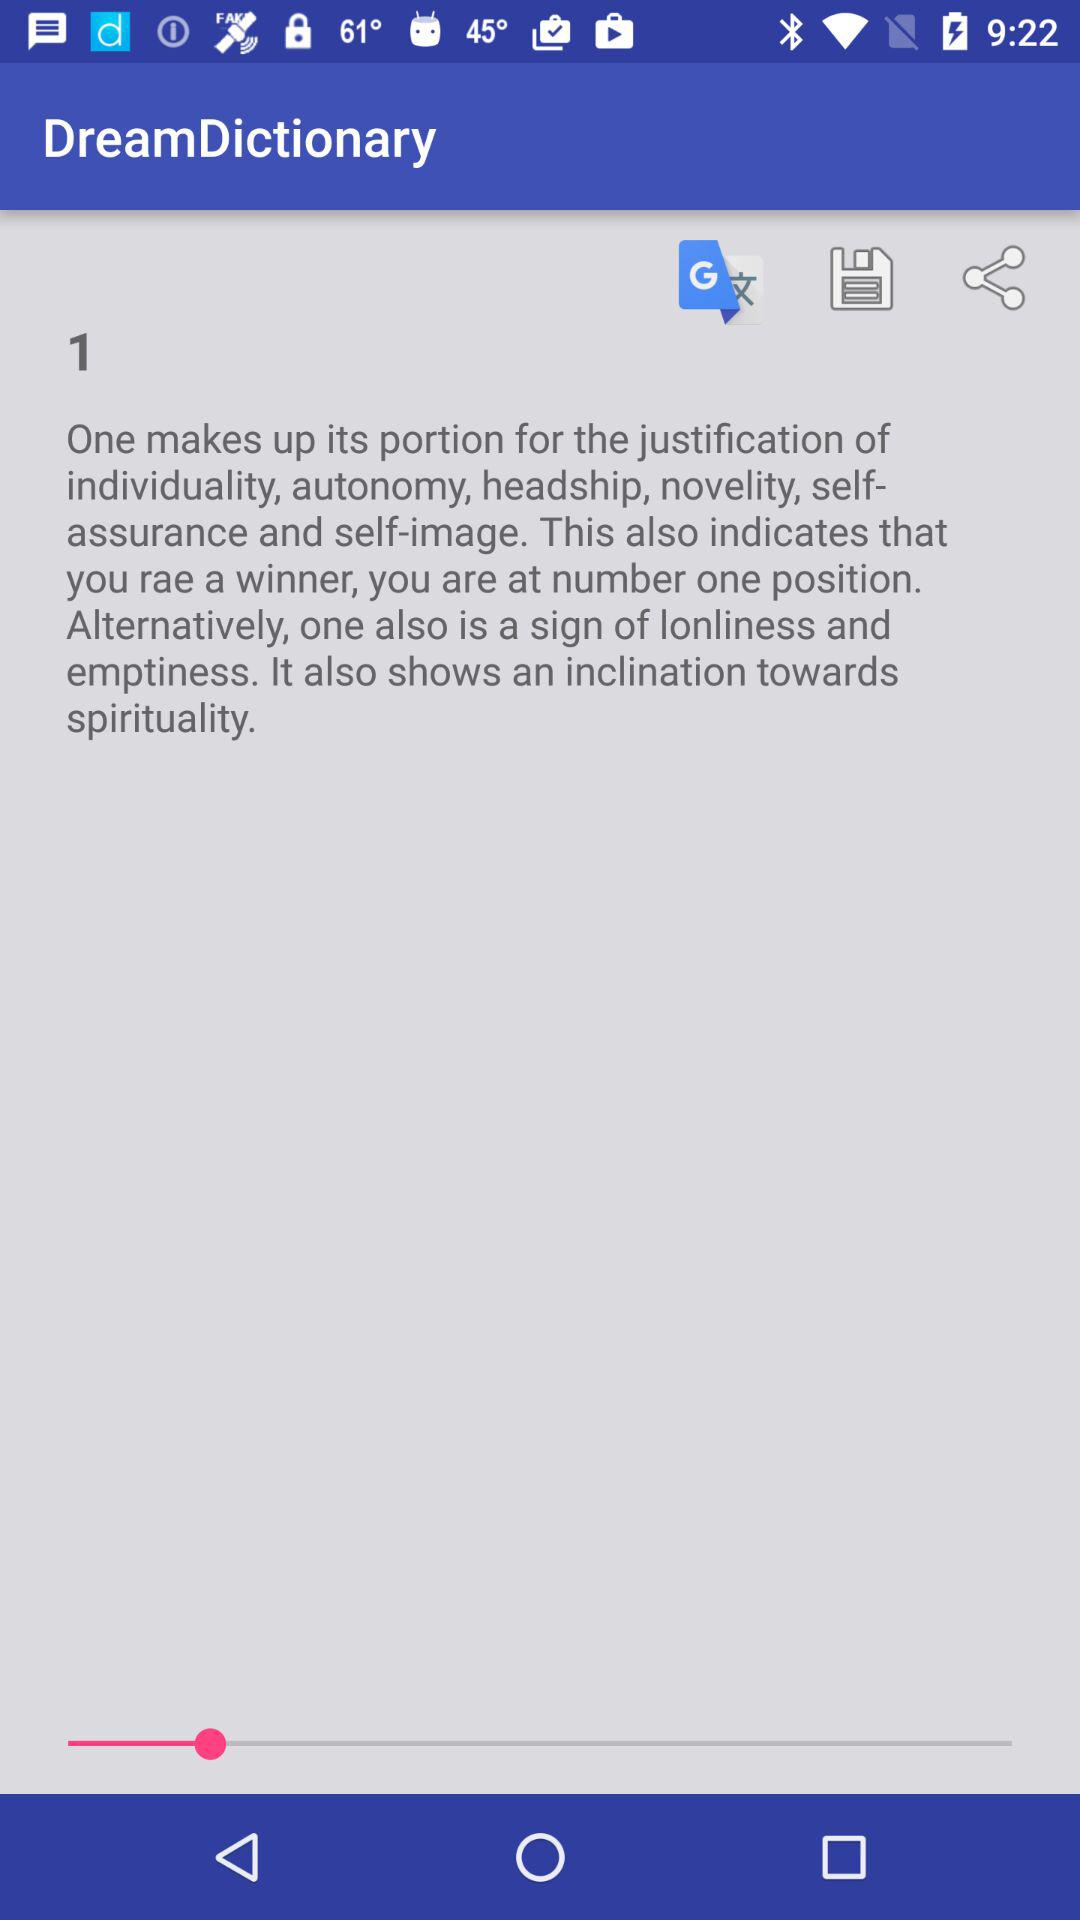What is the name of the application? The name of the application is "DreamDictionary". 